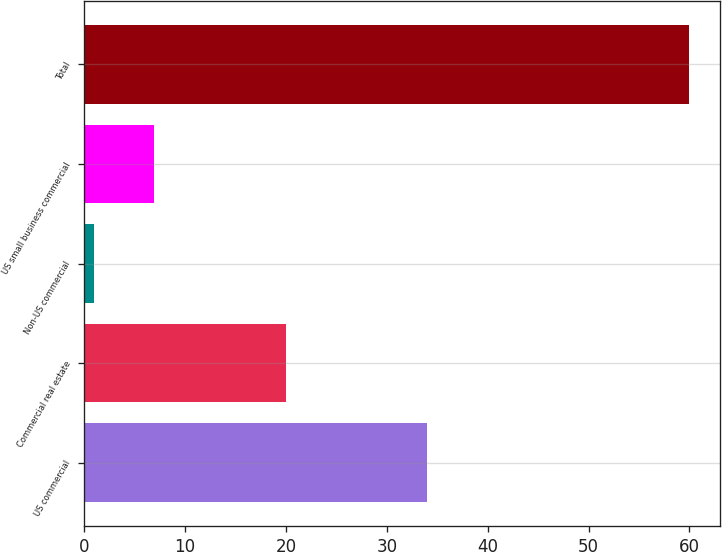Convert chart to OTSL. <chart><loc_0><loc_0><loc_500><loc_500><bar_chart><fcel>US commercial<fcel>Commercial real estate<fcel>Non-US commercial<fcel>US small business commercial<fcel>Total<nl><fcel>34<fcel>20<fcel>1<fcel>6.9<fcel>60<nl></chart> 